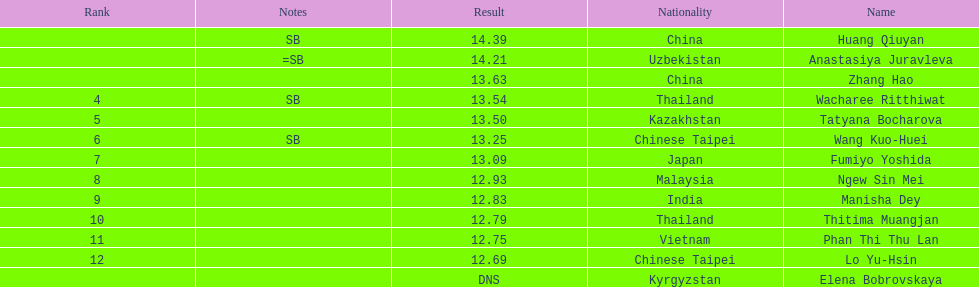How many athletes had a better result than tatyana bocharova? 4. 